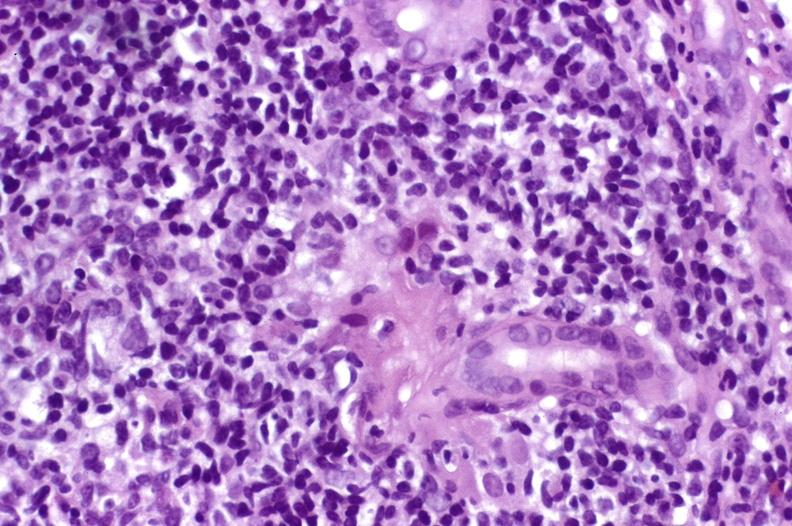s a bulge present?
Answer the question using a single word or phrase. No 